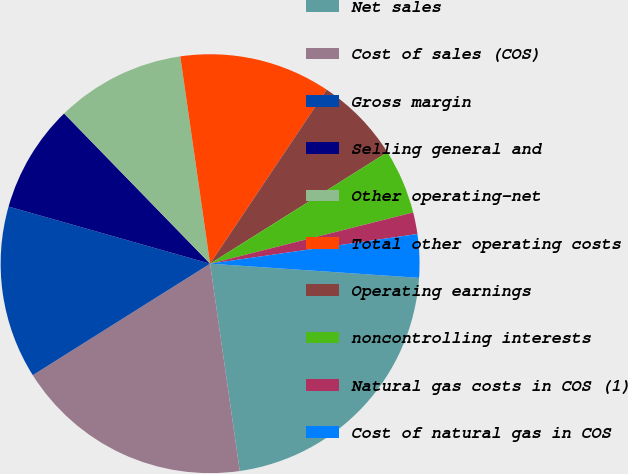Convert chart. <chart><loc_0><loc_0><loc_500><loc_500><pie_chart><fcel>Net sales<fcel>Cost of sales (COS)<fcel>Gross margin<fcel>Selling general and<fcel>Other operating-net<fcel>Total other operating costs<fcel>Operating earnings<fcel>noncontrolling interests<fcel>Natural gas costs in COS (1)<fcel>Cost of natural gas in COS<nl><fcel>21.66%<fcel>18.33%<fcel>13.33%<fcel>8.33%<fcel>10.0%<fcel>11.67%<fcel>6.67%<fcel>5.0%<fcel>1.67%<fcel>3.34%<nl></chart> 